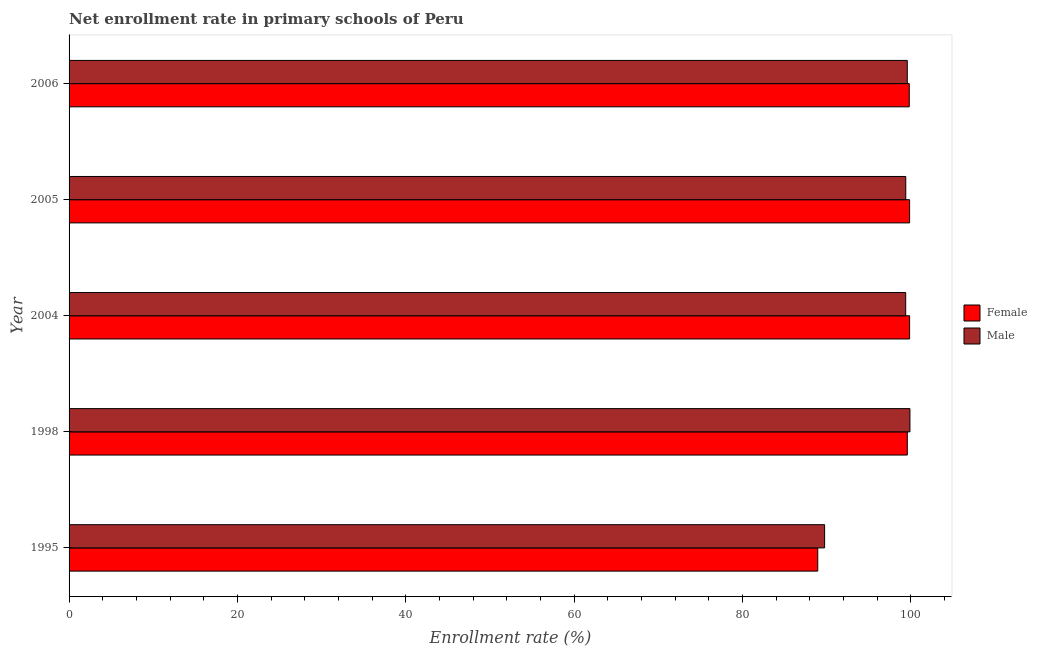How many groups of bars are there?
Keep it short and to the point. 5. How many bars are there on the 4th tick from the top?
Your answer should be compact. 2. What is the label of the 1st group of bars from the top?
Make the answer very short. 2006. In how many cases, is the number of bars for a given year not equal to the number of legend labels?
Offer a very short reply. 0. What is the enrollment rate of male students in 1998?
Offer a very short reply. 99.91. Across all years, what is the maximum enrollment rate of female students?
Make the answer very short. 99.87. Across all years, what is the minimum enrollment rate of male students?
Provide a succinct answer. 89.77. In which year was the enrollment rate of male students maximum?
Make the answer very short. 1998. In which year was the enrollment rate of male students minimum?
Offer a terse response. 1995. What is the total enrollment rate of male students in the graph?
Make the answer very short. 488.1. What is the difference between the enrollment rate of male students in 1998 and that in 2005?
Keep it short and to the point. 0.49. What is the difference between the enrollment rate of male students in 1998 and the enrollment rate of female students in 2006?
Make the answer very short. 0.08. What is the average enrollment rate of female students per year?
Provide a succinct answer. 97.62. In the year 2006, what is the difference between the enrollment rate of female students and enrollment rate of male students?
Keep it short and to the point. 0.23. In how many years, is the enrollment rate of female students greater than 40 %?
Your response must be concise. 5. Is the difference between the enrollment rate of male students in 1995 and 2005 greater than the difference between the enrollment rate of female students in 1995 and 2005?
Provide a succinct answer. Yes. What is the difference between the highest and the second highest enrollment rate of male students?
Provide a short and direct response. 0.32. What is the difference between the highest and the lowest enrollment rate of male students?
Ensure brevity in your answer.  10.14. In how many years, is the enrollment rate of female students greater than the average enrollment rate of female students taken over all years?
Give a very brief answer. 4. Is the sum of the enrollment rate of female students in 1995 and 1998 greater than the maximum enrollment rate of male students across all years?
Keep it short and to the point. Yes. Are all the bars in the graph horizontal?
Your answer should be compact. Yes. Does the graph contain any zero values?
Make the answer very short. No. Where does the legend appear in the graph?
Provide a succinct answer. Center right. What is the title of the graph?
Offer a very short reply. Net enrollment rate in primary schools of Peru. Does "Merchandise imports" appear as one of the legend labels in the graph?
Your answer should be very brief. No. What is the label or title of the X-axis?
Provide a short and direct response. Enrollment rate (%). What is the label or title of the Y-axis?
Your answer should be compact. Year. What is the Enrollment rate (%) of Female in 1995?
Offer a very short reply. 88.96. What is the Enrollment rate (%) in Male in 1995?
Give a very brief answer. 89.77. What is the Enrollment rate (%) of Female in 1998?
Give a very brief answer. 99.6. What is the Enrollment rate (%) of Male in 1998?
Provide a succinct answer. 99.91. What is the Enrollment rate (%) of Female in 2004?
Provide a succinct answer. 99.87. What is the Enrollment rate (%) of Male in 2004?
Your answer should be compact. 99.41. What is the Enrollment rate (%) in Female in 2005?
Your answer should be compact. 99.87. What is the Enrollment rate (%) in Male in 2005?
Provide a succinct answer. 99.41. What is the Enrollment rate (%) in Female in 2006?
Make the answer very short. 99.83. What is the Enrollment rate (%) of Male in 2006?
Your response must be concise. 99.59. Across all years, what is the maximum Enrollment rate (%) of Female?
Make the answer very short. 99.87. Across all years, what is the maximum Enrollment rate (%) of Male?
Your answer should be very brief. 99.91. Across all years, what is the minimum Enrollment rate (%) of Female?
Make the answer very short. 88.96. Across all years, what is the minimum Enrollment rate (%) in Male?
Offer a terse response. 89.77. What is the total Enrollment rate (%) of Female in the graph?
Provide a succinct answer. 488.13. What is the total Enrollment rate (%) of Male in the graph?
Your answer should be compact. 488.1. What is the difference between the Enrollment rate (%) of Female in 1995 and that in 1998?
Make the answer very short. -10.64. What is the difference between the Enrollment rate (%) in Male in 1995 and that in 1998?
Make the answer very short. -10.14. What is the difference between the Enrollment rate (%) in Female in 1995 and that in 2004?
Your answer should be compact. -10.91. What is the difference between the Enrollment rate (%) of Male in 1995 and that in 2004?
Give a very brief answer. -9.63. What is the difference between the Enrollment rate (%) in Female in 1995 and that in 2005?
Your response must be concise. -10.91. What is the difference between the Enrollment rate (%) of Male in 1995 and that in 2005?
Your answer should be very brief. -9.64. What is the difference between the Enrollment rate (%) in Female in 1995 and that in 2006?
Your answer should be very brief. -10.87. What is the difference between the Enrollment rate (%) of Male in 1995 and that in 2006?
Make the answer very short. -9.82. What is the difference between the Enrollment rate (%) in Female in 1998 and that in 2004?
Keep it short and to the point. -0.27. What is the difference between the Enrollment rate (%) of Male in 1998 and that in 2004?
Ensure brevity in your answer.  0.5. What is the difference between the Enrollment rate (%) in Female in 1998 and that in 2005?
Make the answer very short. -0.27. What is the difference between the Enrollment rate (%) in Male in 1998 and that in 2005?
Provide a short and direct response. 0.49. What is the difference between the Enrollment rate (%) of Female in 1998 and that in 2006?
Offer a terse response. -0.23. What is the difference between the Enrollment rate (%) in Male in 1998 and that in 2006?
Your answer should be very brief. 0.31. What is the difference between the Enrollment rate (%) in Female in 2004 and that in 2005?
Provide a short and direct response. 0. What is the difference between the Enrollment rate (%) in Male in 2004 and that in 2005?
Your answer should be compact. -0.01. What is the difference between the Enrollment rate (%) in Female in 2004 and that in 2006?
Offer a terse response. 0.04. What is the difference between the Enrollment rate (%) of Male in 2004 and that in 2006?
Provide a short and direct response. -0.19. What is the difference between the Enrollment rate (%) of Female in 2005 and that in 2006?
Your answer should be very brief. 0.04. What is the difference between the Enrollment rate (%) in Male in 2005 and that in 2006?
Make the answer very short. -0.18. What is the difference between the Enrollment rate (%) in Female in 1995 and the Enrollment rate (%) in Male in 1998?
Your answer should be very brief. -10.95. What is the difference between the Enrollment rate (%) of Female in 1995 and the Enrollment rate (%) of Male in 2004?
Ensure brevity in your answer.  -10.45. What is the difference between the Enrollment rate (%) in Female in 1995 and the Enrollment rate (%) in Male in 2005?
Make the answer very short. -10.46. What is the difference between the Enrollment rate (%) of Female in 1995 and the Enrollment rate (%) of Male in 2006?
Give a very brief answer. -10.64. What is the difference between the Enrollment rate (%) of Female in 1998 and the Enrollment rate (%) of Male in 2004?
Offer a terse response. 0.19. What is the difference between the Enrollment rate (%) in Female in 1998 and the Enrollment rate (%) in Male in 2005?
Your answer should be very brief. 0.18. What is the difference between the Enrollment rate (%) in Female in 1998 and the Enrollment rate (%) in Male in 2006?
Offer a very short reply. 0. What is the difference between the Enrollment rate (%) of Female in 2004 and the Enrollment rate (%) of Male in 2005?
Offer a terse response. 0.46. What is the difference between the Enrollment rate (%) in Female in 2004 and the Enrollment rate (%) in Male in 2006?
Your answer should be very brief. 0.28. What is the difference between the Enrollment rate (%) of Female in 2005 and the Enrollment rate (%) of Male in 2006?
Your answer should be compact. 0.27. What is the average Enrollment rate (%) in Female per year?
Your answer should be compact. 97.63. What is the average Enrollment rate (%) in Male per year?
Keep it short and to the point. 97.62. In the year 1995, what is the difference between the Enrollment rate (%) in Female and Enrollment rate (%) in Male?
Give a very brief answer. -0.81. In the year 1998, what is the difference between the Enrollment rate (%) of Female and Enrollment rate (%) of Male?
Ensure brevity in your answer.  -0.31. In the year 2004, what is the difference between the Enrollment rate (%) of Female and Enrollment rate (%) of Male?
Your answer should be very brief. 0.47. In the year 2005, what is the difference between the Enrollment rate (%) in Female and Enrollment rate (%) in Male?
Your answer should be very brief. 0.45. In the year 2006, what is the difference between the Enrollment rate (%) of Female and Enrollment rate (%) of Male?
Your response must be concise. 0.24. What is the ratio of the Enrollment rate (%) in Female in 1995 to that in 1998?
Your answer should be very brief. 0.89. What is the ratio of the Enrollment rate (%) in Male in 1995 to that in 1998?
Offer a very short reply. 0.9. What is the ratio of the Enrollment rate (%) in Female in 1995 to that in 2004?
Provide a short and direct response. 0.89. What is the ratio of the Enrollment rate (%) of Male in 1995 to that in 2004?
Offer a very short reply. 0.9. What is the ratio of the Enrollment rate (%) of Female in 1995 to that in 2005?
Give a very brief answer. 0.89. What is the ratio of the Enrollment rate (%) in Male in 1995 to that in 2005?
Keep it short and to the point. 0.9. What is the ratio of the Enrollment rate (%) of Female in 1995 to that in 2006?
Your answer should be compact. 0.89. What is the ratio of the Enrollment rate (%) in Male in 1995 to that in 2006?
Give a very brief answer. 0.9. What is the ratio of the Enrollment rate (%) of Female in 1998 to that in 2004?
Your answer should be very brief. 1. What is the ratio of the Enrollment rate (%) of Male in 1998 to that in 2004?
Provide a short and direct response. 1.01. What is the ratio of the Enrollment rate (%) in Female in 1998 to that in 2006?
Offer a very short reply. 1. What is the ratio of the Enrollment rate (%) of Male in 1998 to that in 2006?
Your response must be concise. 1. What is the ratio of the Enrollment rate (%) of Female in 2004 to that in 2006?
Your answer should be compact. 1. What is the ratio of the Enrollment rate (%) in Female in 2005 to that in 2006?
Give a very brief answer. 1. What is the ratio of the Enrollment rate (%) in Male in 2005 to that in 2006?
Offer a very short reply. 1. What is the difference between the highest and the second highest Enrollment rate (%) of Female?
Provide a succinct answer. 0. What is the difference between the highest and the second highest Enrollment rate (%) of Male?
Ensure brevity in your answer.  0.31. What is the difference between the highest and the lowest Enrollment rate (%) in Female?
Offer a very short reply. 10.91. What is the difference between the highest and the lowest Enrollment rate (%) in Male?
Your answer should be very brief. 10.14. 